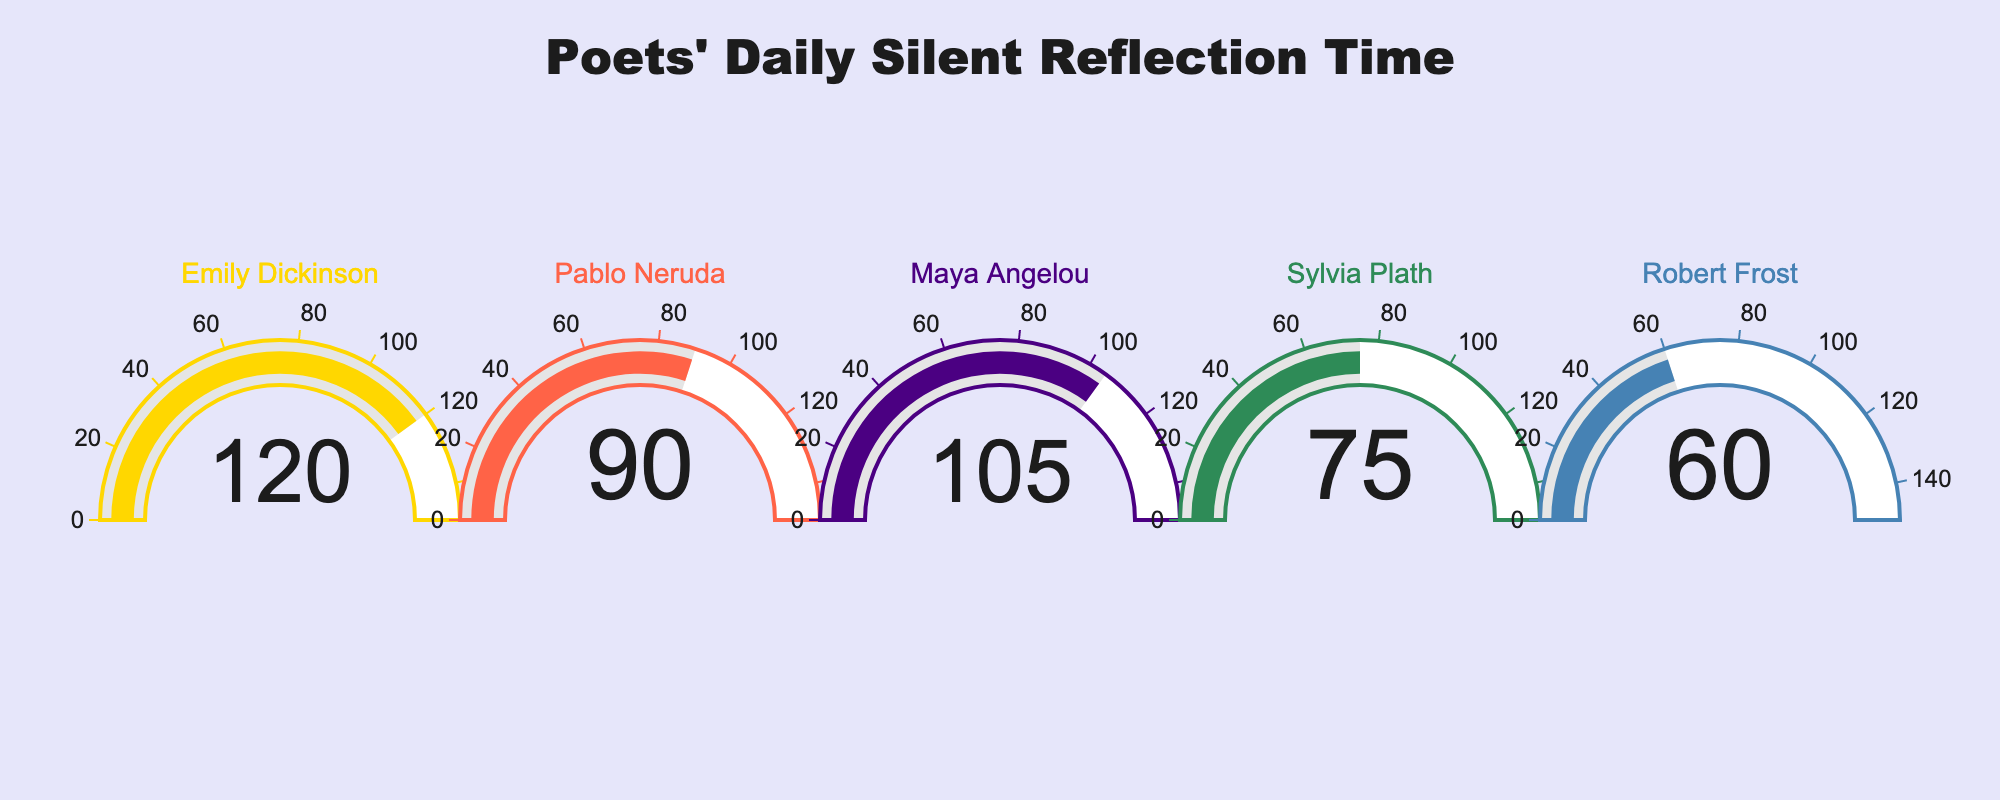What's the title of the figure? The title of the figure appears prominently at the top. It reads "Poets' Daily Silent Reflection Time".
Answer: Poets' Daily Silent Reflection Time How many poets are represented in the figure? To find the number of poets, count the number of gauges present in the figure. There are five gauges.
Answer: Five Which poet spends the most time in silent reflection per day? Look for the gauge with the highest number. Emily Dickinson's gauge shows 120 minutes.
Answer: Emily Dickinson What's the sum of the average silent reflection times for all poets? Add up the values from each gauge: 120 + 90 + 105 + 75 + 60 = 450 minutes.
Answer: 450 minutes Who spends 105 minutes per day in silent reflection? Look at the gauge indicating 105 minutes. It belongs to Maya Angelou.
Answer: Maya Angelou What's the difference between the highest and lowest average silent reflection times? Subtract the lowest value from the highest value: 120 (Emily Dickinson) - 60 (Robert Frost) = 60 minutes.
Answer: 60 minutes Which poets spend less than 100 minutes per day in silent reflection? Identify the poets with values lower than 100 minutes: Sylvia Plath (75 minutes) and Robert Frost (60 minutes).
Answer: Sylvia Plath and Robert Frost What's the average silent reflection time across all poets? Calculate the mean: (120 + 90 + 105 + 75 + 60) / 5 = 90 minutes per day.
Answer: 90 minutes per day Is there any poet whose silent reflection time is exactly the midpoint of the highest and lowest times? Calculate the midpoint: (120 + 60) / 2 = 90 minutes. Pablo Neruda's reflection time is 90 minutes, matching the midpoint.
Answer: Yes, Pablo Neruda 